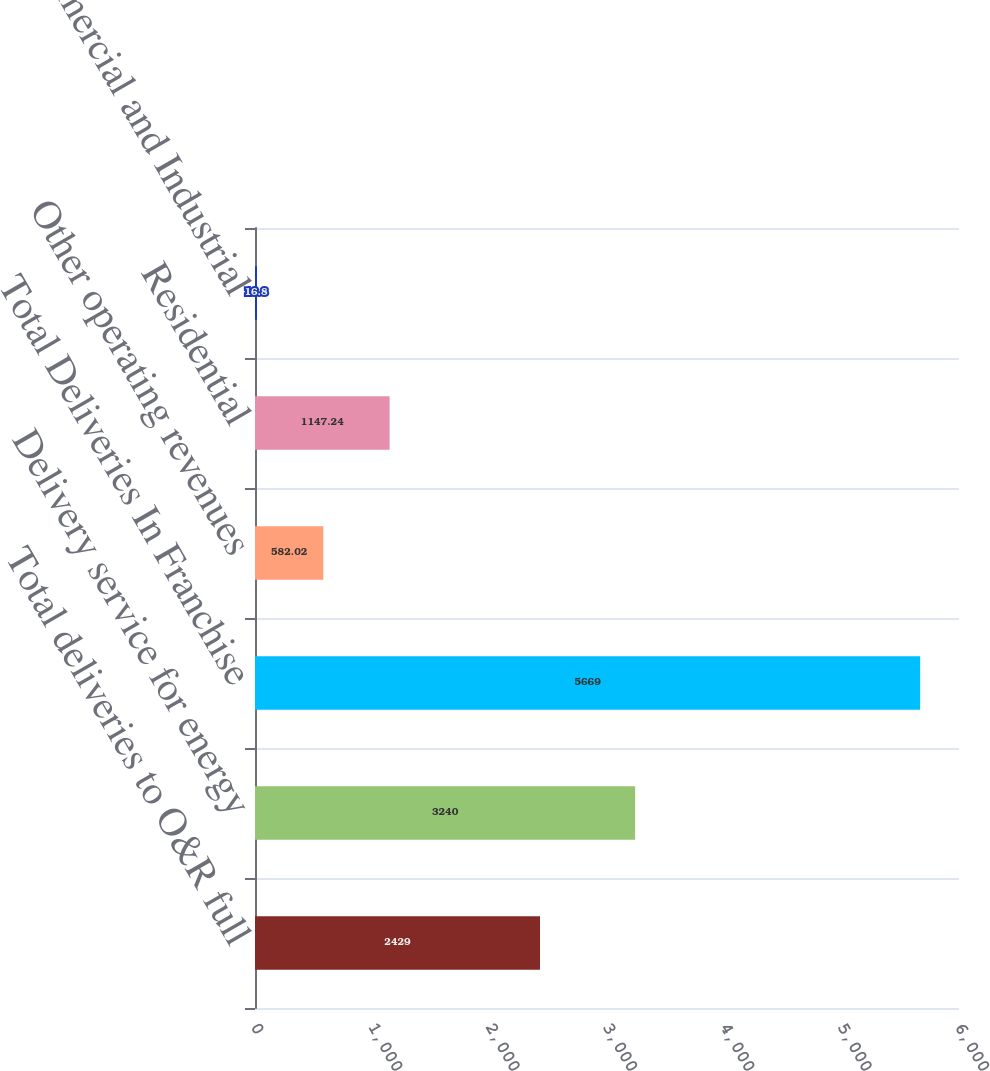Convert chart to OTSL. <chart><loc_0><loc_0><loc_500><loc_500><bar_chart><fcel>Total deliveries to O&R full<fcel>Delivery service for energy<fcel>Total Deliveries In Franchise<fcel>Other operating revenues<fcel>Residential<fcel>Commercial and Industrial<nl><fcel>2429<fcel>3240<fcel>5669<fcel>582.02<fcel>1147.24<fcel>16.8<nl></chart> 